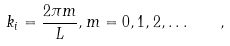Convert formula to latex. <formula><loc_0><loc_0><loc_500><loc_500>k _ { i } = \frac { 2 \pi m } { L } , m = 0 , 1 , 2 , \dots \quad ,</formula> 